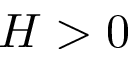<formula> <loc_0><loc_0><loc_500><loc_500>H > 0</formula> 